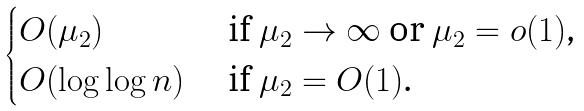<formula> <loc_0><loc_0><loc_500><loc_500>\begin{cases} O ( \mu _ { 2 } ) & \text { if $\mu_{2}\to\infty$ or $\mu_{2}=o(1)$,} \\ O ( \log \log n ) & \text { if $\mu_{2} = O(1)$.} \end{cases}</formula> 